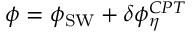Convert formula to latex. <formula><loc_0><loc_0><loc_500><loc_500>\phi = \phi _ { S W } + \delta \phi _ { \eta } ^ { C P T }</formula> 